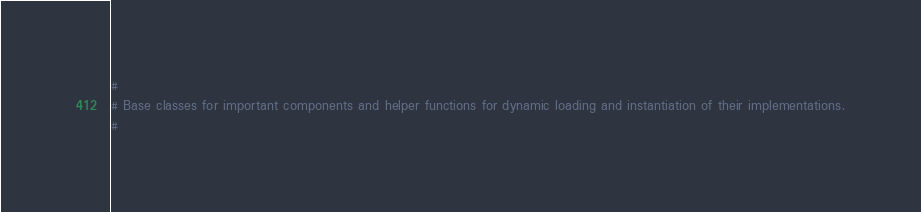Convert code to text. <code><loc_0><loc_0><loc_500><loc_500><_Python_>#
# Base classes for important components and helper functions for dynamic loading and instantiation of their implementations.
#
</code> 